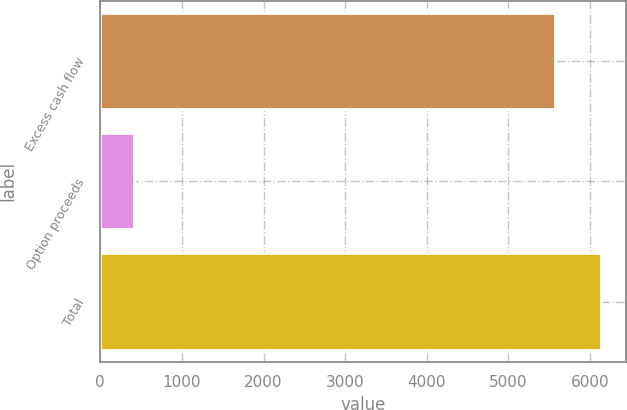<chart> <loc_0><loc_0><loc_500><loc_500><bar_chart><fcel>Excess cash flow<fcel>Option proceeds<fcel>Total<nl><fcel>5575<fcel>415<fcel>6132.5<nl></chart> 